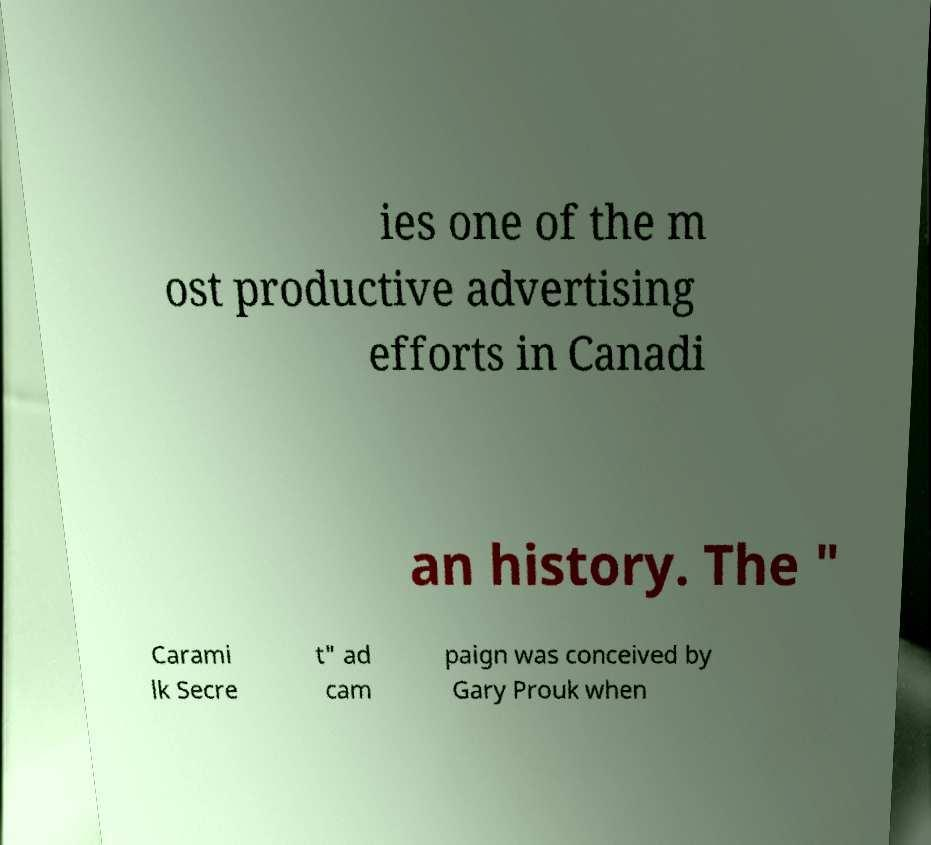There's text embedded in this image that I need extracted. Can you transcribe it verbatim? ies one of the m ost productive advertising efforts in Canadi an history. The " Carami lk Secre t" ad cam paign was conceived by Gary Prouk when 